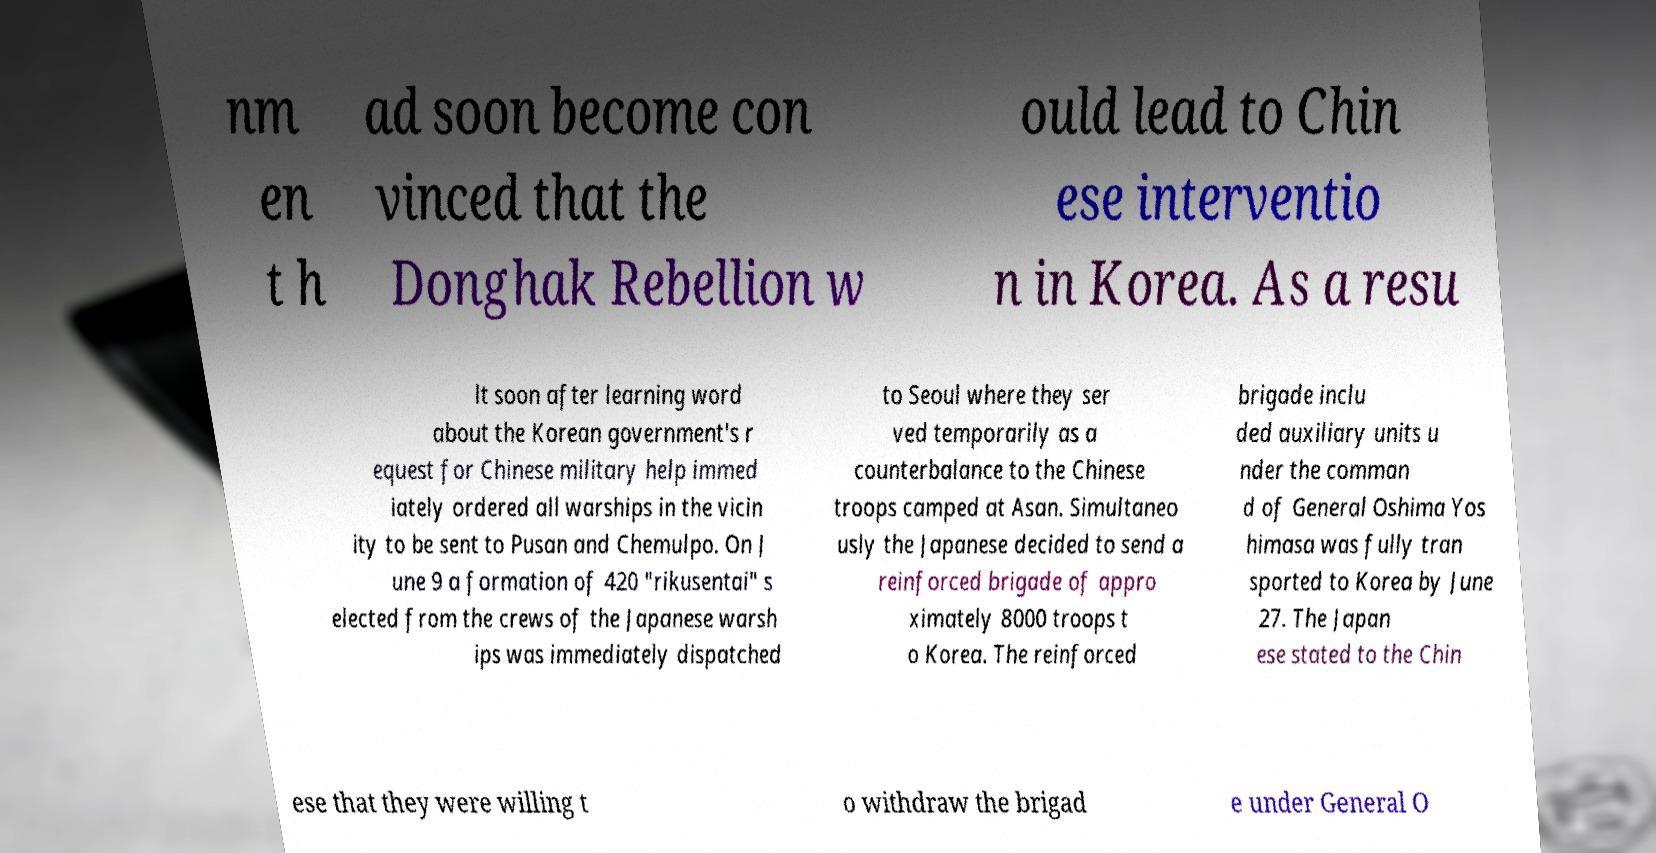For documentation purposes, I need the text within this image transcribed. Could you provide that? nm en t h ad soon become con vinced that the Donghak Rebellion w ould lead to Chin ese interventio n in Korea. As a resu lt soon after learning word about the Korean government's r equest for Chinese military help immed iately ordered all warships in the vicin ity to be sent to Pusan and Chemulpo. On J une 9 a formation of 420 "rikusentai" s elected from the crews of the Japanese warsh ips was immediately dispatched to Seoul where they ser ved temporarily as a counterbalance to the Chinese troops camped at Asan. Simultaneo usly the Japanese decided to send a reinforced brigade of appro ximately 8000 troops t o Korea. The reinforced brigade inclu ded auxiliary units u nder the comman d of General Oshima Yos himasa was fully tran sported to Korea by June 27. The Japan ese stated to the Chin ese that they were willing t o withdraw the brigad e under General O 